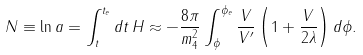Convert formula to latex. <formula><loc_0><loc_0><loc_500><loc_500>N \equiv \ln a = \int ^ { t _ { e } } _ { t } d t \, H \approx - \frac { 8 \pi } { m _ { 4 } ^ { 2 } } \int ^ { \phi _ { e } } _ { \phi } \frac { V } { V ^ { \prime } } \left ( 1 + \frac { V } { 2 \lambda } \right ) d \phi .</formula> 